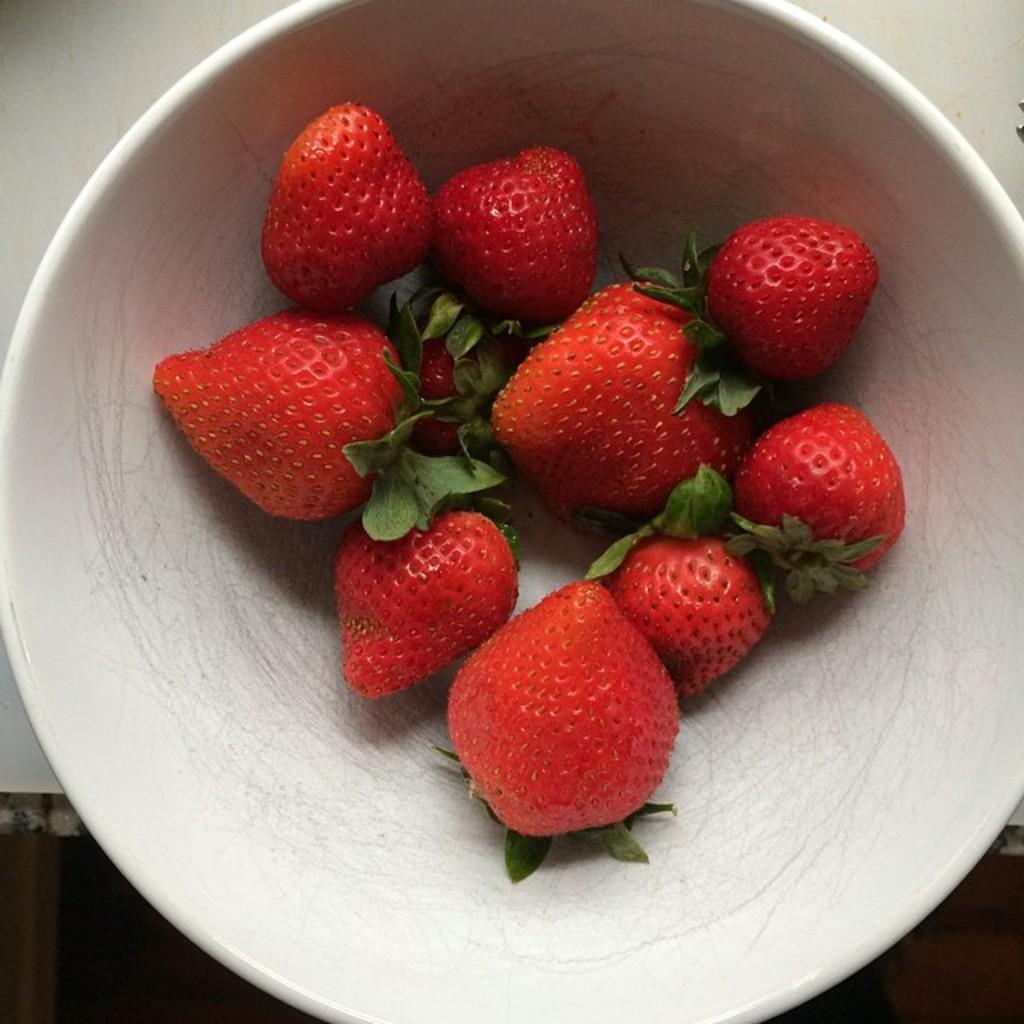What is located on the table in the image? There is a bowl on the table in the image. What is inside the bowl? There are strawberries in the bowl. Can you describe the setting where the bowl is located? The bowl is placed on a table, which suggests it might be in a dining area or kitchen. What type of doll is sitting next to the bowl of strawberries? There is no doll present in the image; it only features a bowl with strawberries on a table. 